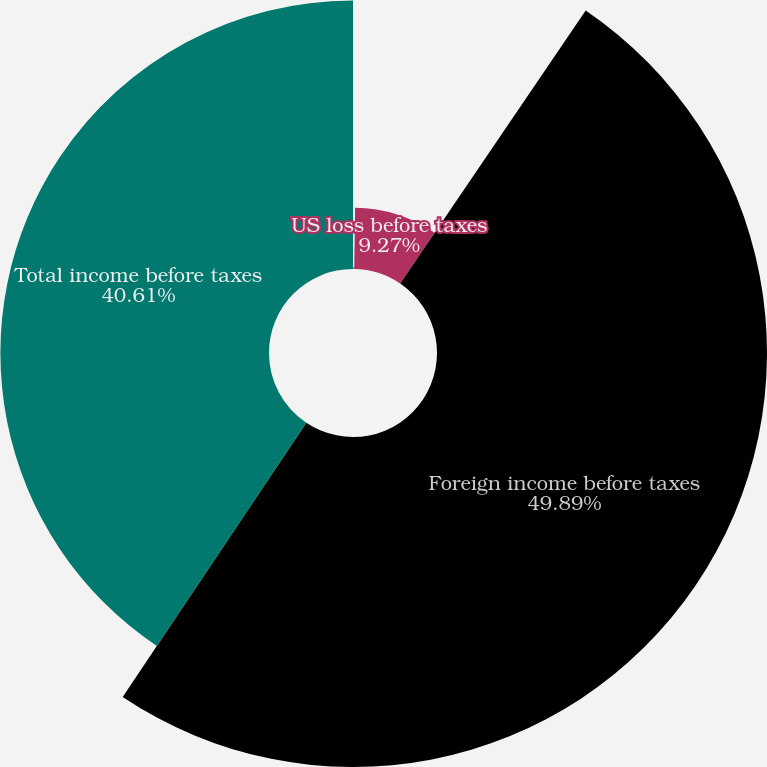<chart> <loc_0><loc_0><loc_500><loc_500><pie_chart><fcel>(DOLLARS IN THOUSANDS)<fcel>US loss before taxes<fcel>Foreign income before taxes<fcel>Total income before taxes<nl><fcel>0.23%<fcel>9.27%<fcel>49.89%<fcel>40.61%<nl></chart> 